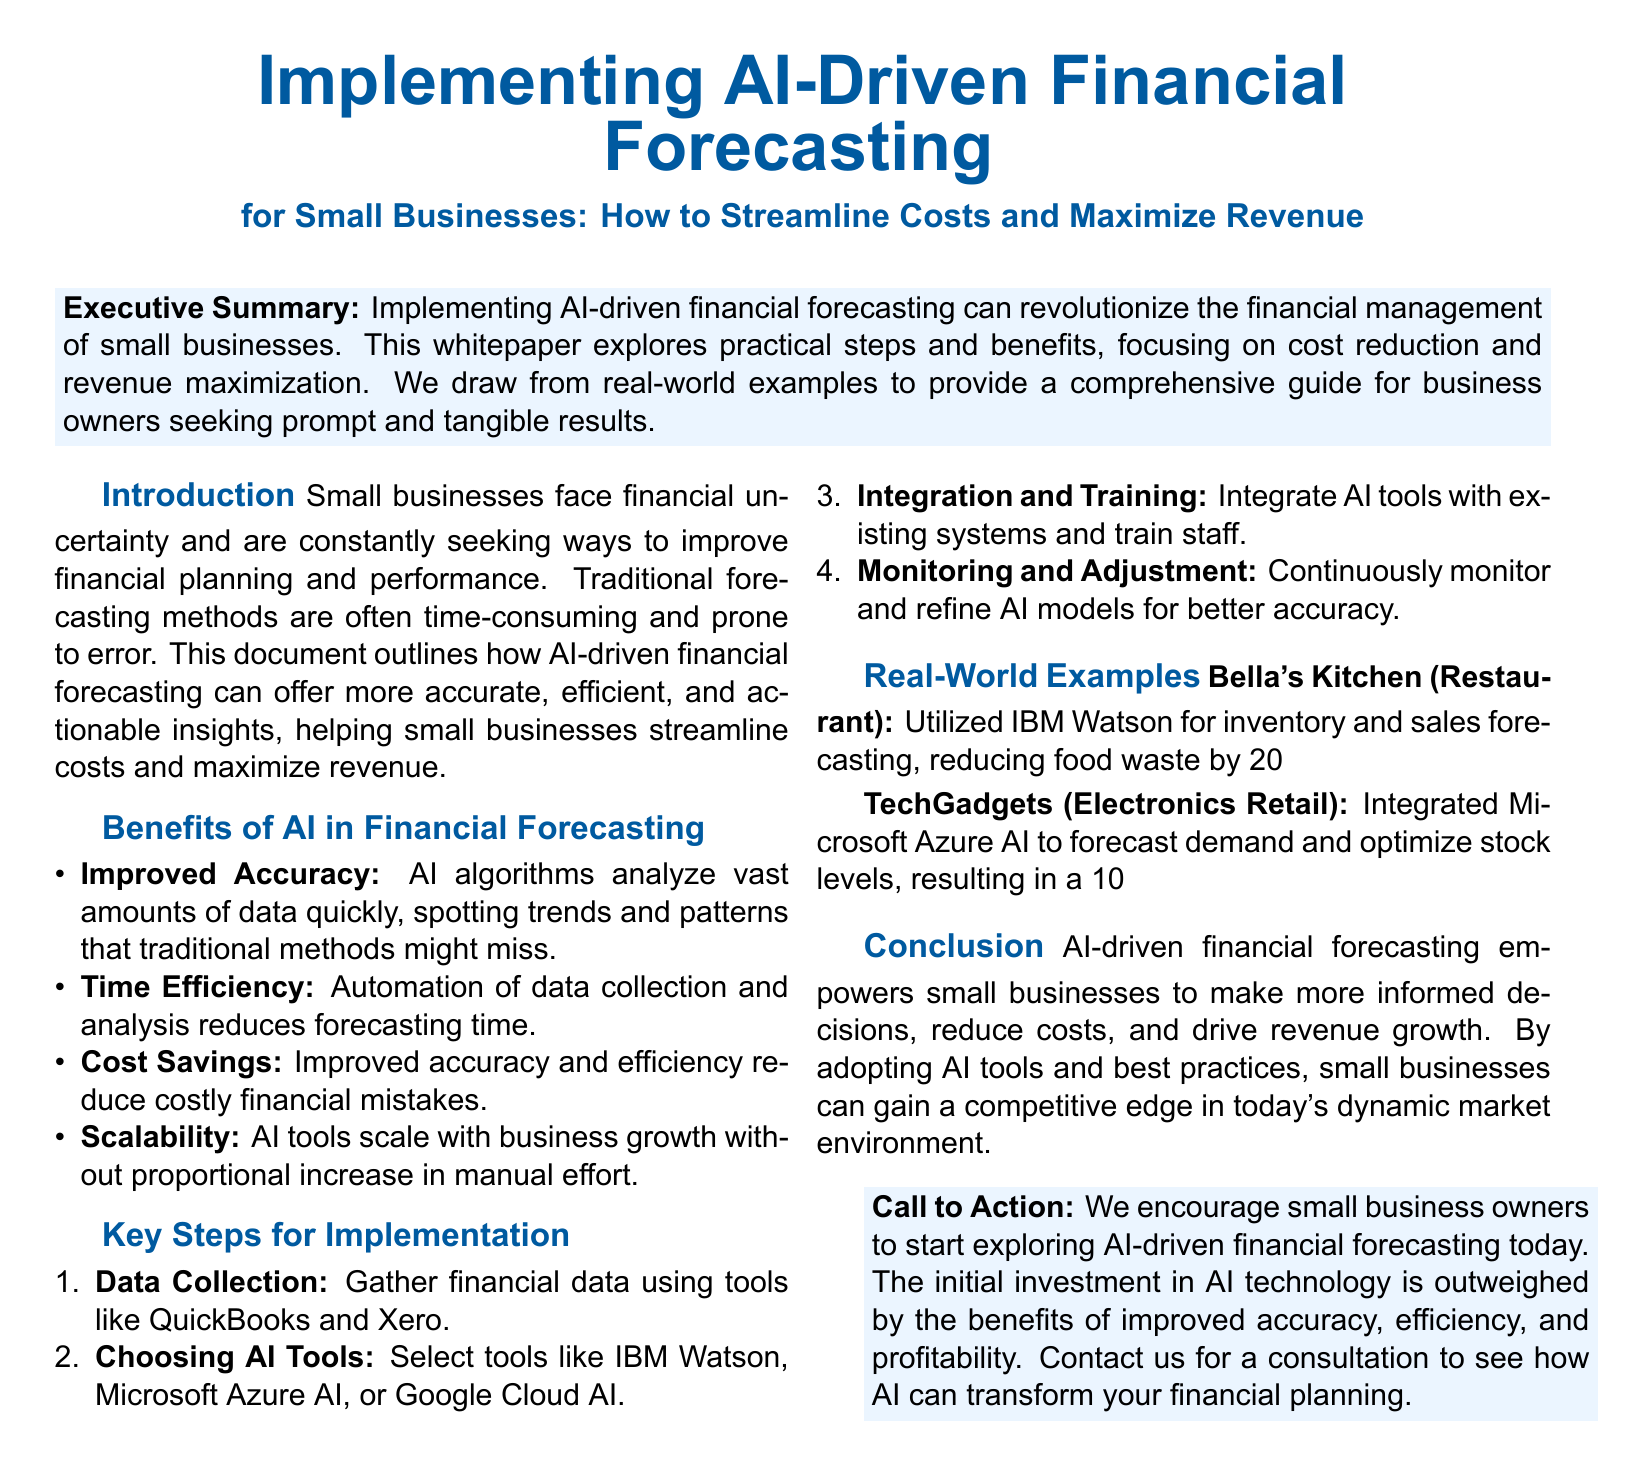What is the main focus of the whitepaper? The main focus of the whitepaper is on the implementation of AI-driven financial forecasting for small businesses, emphasizing cost streamlining and revenue maximization.
Answer: AI-driven financial forecasting What tools are suggested for data collection? Tools mentioned for data collection include QuickBooks and Xero.
Answer: QuickBooks and Xero How much did Bella's Kitchen increase its revenue by? Bella's Kitchen increased its revenue by 15% within six months after implementing AI forecasting.
Answer: 15% What is the first key step in the implementation process? The first key step involves gathering financial data.
Answer: Data Collection What advantage does AI offer in financial forecasting compared to traditional methods? AI algorithms provide improved accuracy by analyzing vast amounts of data quickly.
Answer: Improved Accuracy Which AI tool was used by TechGadgets? TechGadgets utilized Microsoft Azure AI for demand forecasting.
Answer: Microsoft Azure AI What is the recommended action for small business owners at the end of the document? The recommended action is to start exploring AI-driven financial forecasting.
Answer: Start exploring AI-driven financial forecasting What percentage of cost reduction did TechGadgets achieve in inventory management? TechGadgets achieved a 10% cost reduction in inventory management through the use of AI.
Answer: 10% What was the total benefit of implementing AI according to the conclusion? The total benefit mentioned is the empowerment of small businesses in decision-making and financial management.
Answer: Empowered decision-making How does AI affect scalability for small businesses? AI tools can scale with business growth without proportional increase in manual effort.
Answer: Scales without proportional increase in manual effort 